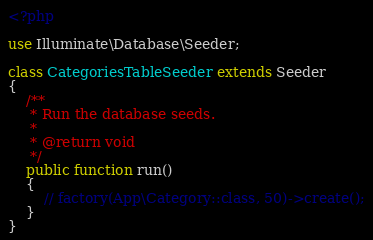<code> <loc_0><loc_0><loc_500><loc_500><_PHP_><?php

use Illuminate\Database\Seeder;

class CategoriesTableSeeder extends Seeder
{
    /**
     * Run the database seeds.
     *
     * @return void
     */
    public function run()
    {
        // factory(App\Category::class, 50)->create();
    }
}
</code> 